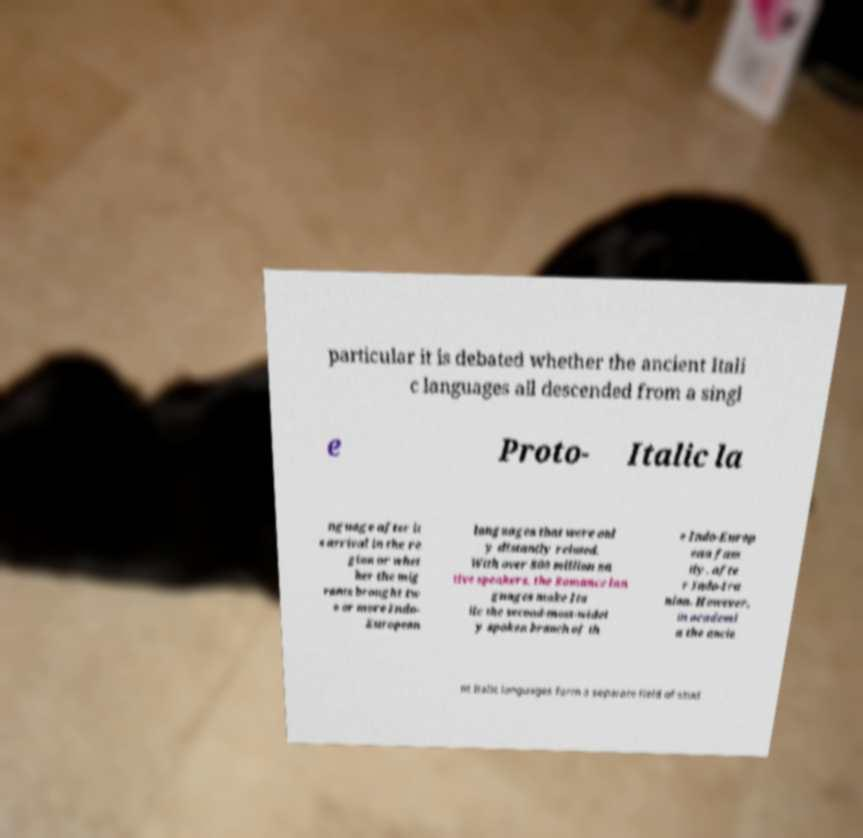Can you read and provide the text displayed in the image?This photo seems to have some interesting text. Can you extract and type it out for me? particular it is debated whether the ancient Itali c languages all descended from a singl e Proto- Italic la nguage after it s arrival in the re gion or whet her the mig rants brought tw o or more Indo- European languages that were onl y distantly related. With over 800 million na tive speakers, the Romance lan guages make Ita lic the second-most-widel y spoken branch of th e Indo-Europ ean fam ily, afte r Indo-Ira nian. However, in academi a the ancie nt Italic languages form a separate field of stud 